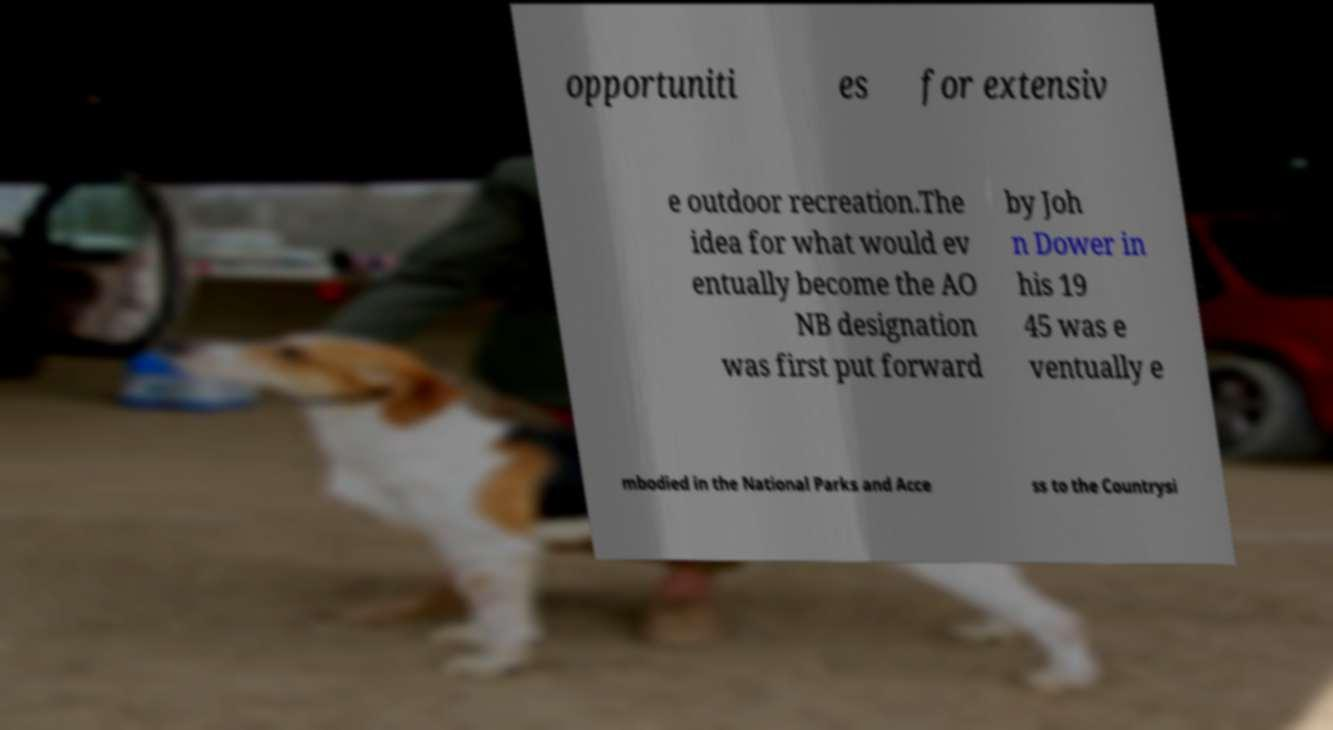What messages or text are displayed in this image? I need them in a readable, typed format. opportuniti es for extensiv e outdoor recreation.The idea for what would ev entually become the AO NB designation was first put forward by Joh n Dower in his 19 45 was e ventually e mbodied in the National Parks and Acce ss to the Countrysi 